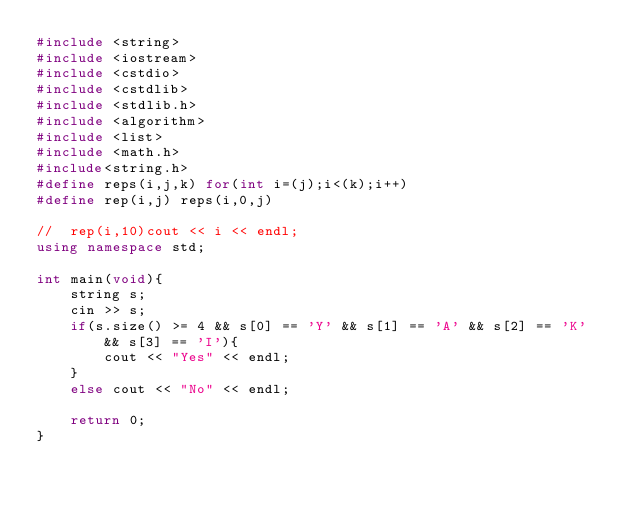<code> <loc_0><loc_0><loc_500><loc_500><_C++_>#include <string>
#include <iostream>
#include <cstdio>
#include <cstdlib>
#include <stdlib.h>
#include <algorithm>
#include <list>
#include <math.h>
#include<string.h>
#define reps(i,j,k) for(int i=(j);i<(k);i++)
#define rep(i,j) reps(i,0,j)

//	rep(i,10)cout << i << endl;
using namespace std;

int main(void){
	string s;
	cin >> s;
	if(s.size() >= 4 && s[0] == 'Y' && s[1] == 'A' && s[2] == 'K' && s[3] == 'I'){
		cout << "Yes" << endl;
	}
	else cout << "No" << endl;
		
	return 0;
}</code> 